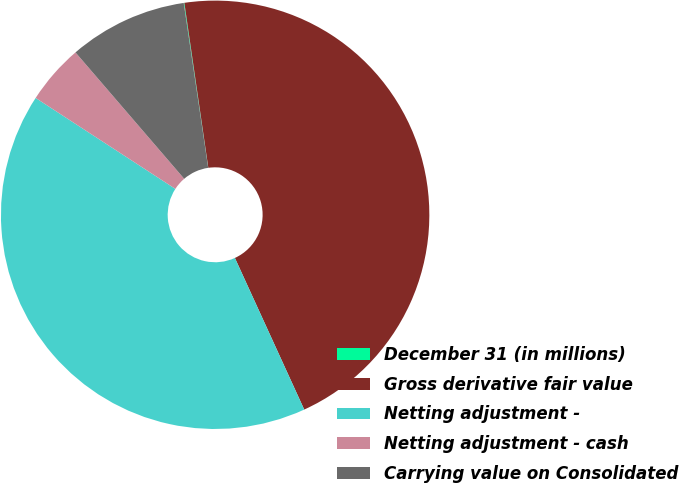Convert chart. <chart><loc_0><loc_0><loc_500><loc_500><pie_chart><fcel>December 31 (in millions)<fcel>Gross derivative fair value<fcel>Netting adjustment -<fcel>Netting adjustment - cash<fcel>Carrying value on Consolidated<nl><fcel>0.05%<fcel>45.47%<fcel>41.01%<fcel>4.51%<fcel>8.96%<nl></chart> 